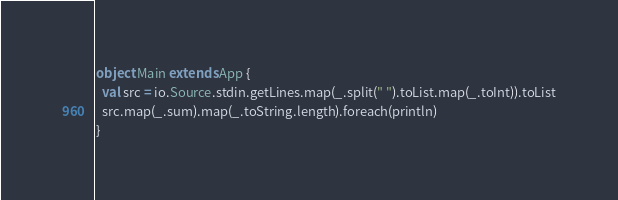Convert code to text. <code><loc_0><loc_0><loc_500><loc_500><_Scala_>object Main extends App {
  val src = io.Source.stdin.getLines.map(_.split(" ").toList.map(_.toInt)).toList
  src.map(_.sum).map(_.toString.length).foreach(println)
}</code> 